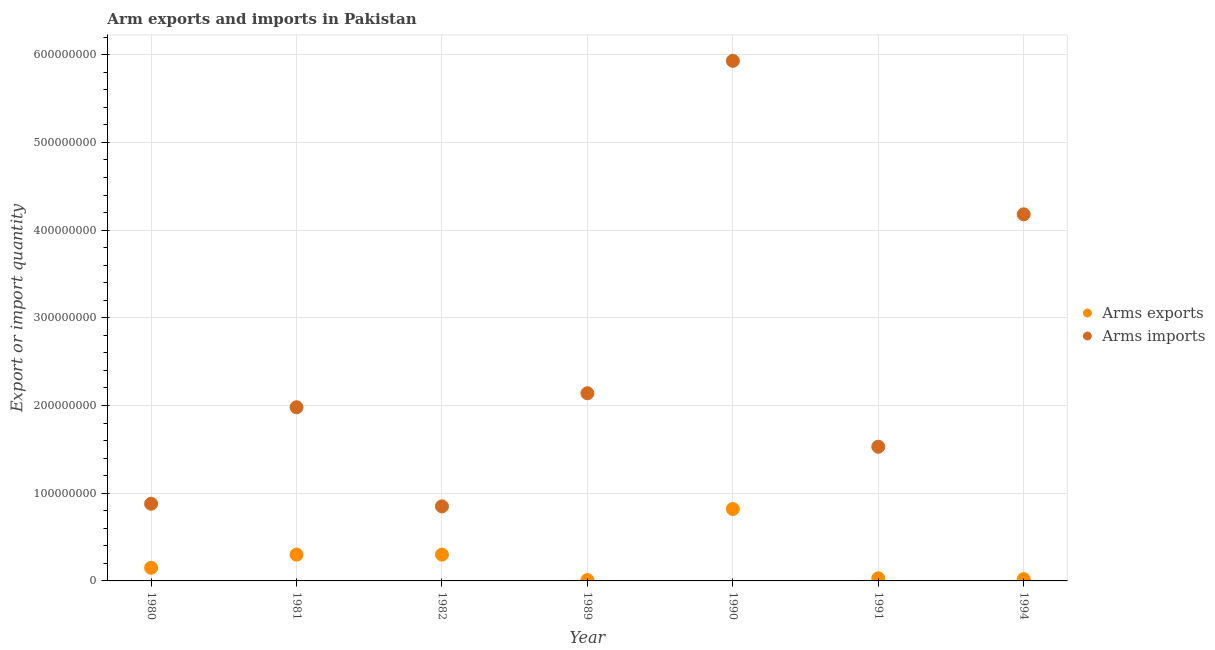What is the arms exports in 1980?
Offer a very short reply. 1.50e+07. Across all years, what is the maximum arms imports?
Offer a terse response. 5.93e+08. Across all years, what is the minimum arms imports?
Make the answer very short. 8.50e+07. In which year was the arms exports minimum?
Your answer should be very brief. 1989. What is the total arms imports in the graph?
Your answer should be very brief. 1.75e+09. What is the difference between the arms exports in 1989 and that in 1991?
Offer a terse response. -2.00e+06. What is the difference between the arms exports in 1994 and the arms imports in 1980?
Ensure brevity in your answer.  -8.60e+07. What is the average arms exports per year?
Give a very brief answer. 2.33e+07. In the year 1991, what is the difference between the arms imports and arms exports?
Offer a terse response. 1.50e+08. In how many years, is the arms exports greater than 380000000?
Offer a very short reply. 0. Is the arms imports in 1982 less than that in 1991?
Your answer should be very brief. Yes. What is the difference between the highest and the second highest arms imports?
Provide a succinct answer. 1.75e+08. What is the difference between the highest and the lowest arms exports?
Make the answer very short. 8.10e+07. In how many years, is the arms imports greater than the average arms imports taken over all years?
Offer a very short reply. 2. Is the sum of the arms imports in 1991 and 1994 greater than the maximum arms exports across all years?
Provide a succinct answer. Yes. Does the arms imports monotonically increase over the years?
Provide a short and direct response. No. How many legend labels are there?
Provide a short and direct response. 2. What is the title of the graph?
Provide a short and direct response. Arm exports and imports in Pakistan. What is the label or title of the Y-axis?
Provide a short and direct response. Export or import quantity. What is the Export or import quantity of Arms exports in 1980?
Keep it short and to the point. 1.50e+07. What is the Export or import quantity in Arms imports in 1980?
Give a very brief answer. 8.80e+07. What is the Export or import quantity of Arms exports in 1981?
Provide a short and direct response. 3.00e+07. What is the Export or import quantity in Arms imports in 1981?
Your answer should be compact. 1.98e+08. What is the Export or import quantity of Arms exports in 1982?
Provide a succinct answer. 3.00e+07. What is the Export or import quantity of Arms imports in 1982?
Your response must be concise. 8.50e+07. What is the Export or import quantity of Arms imports in 1989?
Provide a succinct answer. 2.14e+08. What is the Export or import quantity in Arms exports in 1990?
Provide a succinct answer. 8.20e+07. What is the Export or import quantity of Arms imports in 1990?
Ensure brevity in your answer.  5.93e+08. What is the Export or import quantity of Arms exports in 1991?
Offer a terse response. 3.00e+06. What is the Export or import quantity of Arms imports in 1991?
Make the answer very short. 1.53e+08. What is the Export or import quantity in Arms exports in 1994?
Make the answer very short. 2.00e+06. What is the Export or import quantity in Arms imports in 1994?
Give a very brief answer. 4.18e+08. Across all years, what is the maximum Export or import quantity in Arms exports?
Keep it short and to the point. 8.20e+07. Across all years, what is the maximum Export or import quantity of Arms imports?
Ensure brevity in your answer.  5.93e+08. Across all years, what is the minimum Export or import quantity of Arms exports?
Make the answer very short. 1.00e+06. Across all years, what is the minimum Export or import quantity of Arms imports?
Give a very brief answer. 8.50e+07. What is the total Export or import quantity in Arms exports in the graph?
Provide a succinct answer. 1.63e+08. What is the total Export or import quantity in Arms imports in the graph?
Give a very brief answer. 1.75e+09. What is the difference between the Export or import quantity of Arms exports in 1980 and that in 1981?
Your response must be concise. -1.50e+07. What is the difference between the Export or import quantity of Arms imports in 1980 and that in 1981?
Ensure brevity in your answer.  -1.10e+08. What is the difference between the Export or import quantity in Arms exports in 1980 and that in 1982?
Provide a succinct answer. -1.50e+07. What is the difference between the Export or import quantity in Arms imports in 1980 and that in 1982?
Make the answer very short. 3.00e+06. What is the difference between the Export or import quantity in Arms exports in 1980 and that in 1989?
Your response must be concise. 1.40e+07. What is the difference between the Export or import quantity of Arms imports in 1980 and that in 1989?
Give a very brief answer. -1.26e+08. What is the difference between the Export or import quantity of Arms exports in 1980 and that in 1990?
Provide a succinct answer. -6.70e+07. What is the difference between the Export or import quantity of Arms imports in 1980 and that in 1990?
Your answer should be very brief. -5.05e+08. What is the difference between the Export or import quantity in Arms exports in 1980 and that in 1991?
Offer a terse response. 1.20e+07. What is the difference between the Export or import quantity in Arms imports in 1980 and that in 1991?
Your answer should be compact. -6.50e+07. What is the difference between the Export or import quantity in Arms exports in 1980 and that in 1994?
Offer a very short reply. 1.30e+07. What is the difference between the Export or import quantity of Arms imports in 1980 and that in 1994?
Your answer should be compact. -3.30e+08. What is the difference between the Export or import quantity in Arms imports in 1981 and that in 1982?
Your answer should be very brief. 1.13e+08. What is the difference between the Export or import quantity in Arms exports in 1981 and that in 1989?
Provide a succinct answer. 2.90e+07. What is the difference between the Export or import quantity in Arms imports in 1981 and that in 1989?
Your answer should be compact. -1.60e+07. What is the difference between the Export or import quantity of Arms exports in 1981 and that in 1990?
Offer a terse response. -5.20e+07. What is the difference between the Export or import quantity of Arms imports in 1981 and that in 1990?
Keep it short and to the point. -3.95e+08. What is the difference between the Export or import quantity of Arms exports in 1981 and that in 1991?
Your response must be concise. 2.70e+07. What is the difference between the Export or import quantity in Arms imports in 1981 and that in 1991?
Make the answer very short. 4.50e+07. What is the difference between the Export or import quantity in Arms exports in 1981 and that in 1994?
Offer a terse response. 2.80e+07. What is the difference between the Export or import quantity of Arms imports in 1981 and that in 1994?
Your answer should be compact. -2.20e+08. What is the difference between the Export or import quantity of Arms exports in 1982 and that in 1989?
Offer a terse response. 2.90e+07. What is the difference between the Export or import quantity in Arms imports in 1982 and that in 1989?
Provide a short and direct response. -1.29e+08. What is the difference between the Export or import quantity of Arms exports in 1982 and that in 1990?
Ensure brevity in your answer.  -5.20e+07. What is the difference between the Export or import quantity in Arms imports in 1982 and that in 1990?
Offer a very short reply. -5.08e+08. What is the difference between the Export or import quantity of Arms exports in 1982 and that in 1991?
Offer a very short reply. 2.70e+07. What is the difference between the Export or import quantity of Arms imports in 1982 and that in 1991?
Offer a terse response. -6.80e+07. What is the difference between the Export or import quantity of Arms exports in 1982 and that in 1994?
Your answer should be very brief. 2.80e+07. What is the difference between the Export or import quantity of Arms imports in 1982 and that in 1994?
Your answer should be very brief. -3.33e+08. What is the difference between the Export or import quantity in Arms exports in 1989 and that in 1990?
Ensure brevity in your answer.  -8.10e+07. What is the difference between the Export or import quantity of Arms imports in 1989 and that in 1990?
Keep it short and to the point. -3.79e+08. What is the difference between the Export or import quantity of Arms exports in 1989 and that in 1991?
Keep it short and to the point. -2.00e+06. What is the difference between the Export or import quantity of Arms imports in 1989 and that in 1991?
Keep it short and to the point. 6.10e+07. What is the difference between the Export or import quantity of Arms exports in 1989 and that in 1994?
Your response must be concise. -1.00e+06. What is the difference between the Export or import quantity of Arms imports in 1989 and that in 1994?
Offer a very short reply. -2.04e+08. What is the difference between the Export or import quantity in Arms exports in 1990 and that in 1991?
Ensure brevity in your answer.  7.90e+07. What is the difference between the Export or import quantity of Arms imports in 1990 and that in 1991?
Your answer should be compact. 4.40e+08. What is the difference between the Export or import quantity in Arms exports in 1990 and that in 1994?
Keep it short and to the point. 8.00e+07. What is the difference between the Export or import quantity in Arms imports in 1990 and that in 1994?
Your answer should be very brief. 1.75e+08. What is the difference between the Export or import quantity of Arms exports in 1991 and that in 1994?
Your answer should be compact. 1.00e+06. What is the difference between the Export or import quantity of Arms imports in 1991 and that in 1994?
Your answer should be very brief. -2.65e+08. What is the difference between the Export or import quantity in Arms exports in 1980 and the Export or import quantity in Arms imports in 1981?
Provide a succinct answer. -1.83e+08. What is the difference between the Export or import quantity of Arms exports in 1980 and the Export or import quantity of Arms imports in 1982?
Keep it short and to the point. -7.00e+07. What is the difference between the Export or import quantity of Arms exports in 1980 and the Export or import quantity of Arms imports in 1989?
Your answer should be compact. -1.99e+08. What is the difference between the Export or import quantity of Arms exports in 1980 and the Export or import quantity of Arms imports in 1990?
Make the answer very short. -5.78e+08. What is the difference between the Export or import quantity in Arms exports in 1980 and the Export or import quantity in Arms imports in 1991?
Your answer should be very brief. -1.38e+08. What is the difference between the Export or import quantity in Arms exports in 1980 and the Export or import quantity in Arms imports in 1994?
Ensure brevity in your answer.  -4.03e+08. What is the difference between the Export or import quantity in Arms exports in 1981 and the Export or import quantity in Arms imports in 1982?
Your answer should be compact. -5.50e+07. What is the difference between the Export or import quantity of Arms exports in 1981 and the Export or import quantity of Arms imports in 1989?
Your answer should be compact. -1.84e+08. What is the difference between the Export or import quantity in Arms exports in 1981 and the Export or import quantity in Arms imports in 1990?
Your answer should be compact. -5.63e+08. What is the difference between the Export or import quantity in Arms exports in 1981 and the Export or import quantity in Arms imports in 1991?
Your response must be concise. -1.23e+08. What is the difference between the Export or import quantity of Arms exports in 1981 and the Export or import quantity of Arms imports in 1994?
Provide a short and direct response. -3.88e+08. What is the difference between the Export or import quantity in Arms exports in 1982 and the Export or import quantity in Arms imports in 1989?
Your answer should be compact. -1.84e+08. What is the difference between the Export or import quantity in Arms exports in 1982 and the Export or import quantity in Arms imports in 1990?
Your response must be concise. -5.63e+08. What is the difference between the Export or import quantity of Arms exports in 1982 and the Export or import quantity of Arms imports in 1991?
Ensure brevity in your answer.  -1.23e+08. What is the difference between the Export or import quantity in Arms exports in 1982 and the Export or import quantity in Arms imports in 1994?
Provide a succinct answer. -3.88e+08. What is the difference between the Export or import quantity of Arms exports in 1989 and the Export or import quantity of Arms imports in 1990?
Provide a succinct answer. -5.92e+08. What is the difference between the Export or import quantity in Arms exports in 1989 and the Export or import quantity in Arms imports in 1991?
Make the answer very short. -1.52e+08. What is the difference between the Export or import quantity in Arms exports in 1989 and the Export or import quantity in Arms imports in 1994?
Offer a very short reply. -4.17e+08. What is the difference between the Export or import quantity of Arms exports in 1990 and the Export or import quantity of Arms imports in 1991?
Your answer should be very brief. -7.10e+07. What is the difference between the Export or import quantity of Arms exports in 1990 and the Export or import quantity of Arms imports in 1994?
Offer a very short reply. -3.36e+08. What is the difference between the Export or import quantity of Arms exports in 1991 and the Export or import quantity of Arms imports in 1994?
Keep it short and to the point. -4.15e+08. What is the average Export or import quantity in Arms exports per year?
Offer a very short reply. 2.33e+07. What is the average Export or import quantity in Arms imports per year?
Ensure brevity in your answer.  2.50e+08. In the year 1980, what is the difference between the Export or import quantity in Arms exports and Export or import quantity in Arms imports?
Your answer should be very brief. -7.30e+07. In the year 1981, what is the difference between the Export or import quantity of Arms exports and Export or import quantity of Arms imports?
Your response must be concise. -1.68e+08. In the year 1982, what is the difference between the Export or import quantity of Arms exports and Export or import quantity of Arms imports?
Offer a terse response. -5.50e+07. In the year 1989, what is the difference between the Export or import quantity of Arms exports and Export or import quantity of Arms imports?
Keep it short and to the point. -2.13e+08. In the year 1990, what is the difference between the Export or import quantity of Arms exports and Export or import quantity of Arms imports?
Ensure brevity in your answer.  -5.11e+08. In the year 1991, what is the difference between the Export or import quantity in Arms exports and Export or import quantity in Arms imports?
Make the answer very short. -1.50e+08. In the year 1994, what is the difference between the Export or import quantity of Arms exports and Export or import quantity of Arms imports?
Offer a very short reply. -4.16e+08. What is the ratio of the Export or import quantity in Arms exports in 1980 to that in 1981?
Ensure brevity in your answer.  0.5. What is the ratio of the Export or import quantity of Arms imports in 1980 to that in 1981?
Keep it short and to the point. 0.44. What is the ratio of the Export or import quantity of Arms imports in 1980 to that in 1982?
Keep it short and to the point. 1.04. What is the ratio of the Export or import quantity in Arms exports in 1980 to that in 1989?
Provide a short and direct response. 15. What is the ratio of the Export or import quantity in Arms imports in 1980 to that in 1989?
Provide a short and direct response. 0.41. What is the ratio of the Export or import quantity in Arms exports in 1980 to that in 1990?
Your response must be concise. 0.18. What is the ratio of the Export or import quantity in Arms imports in 1980 to that in 1990?
Offer a very short reply. 0.15. What is the ratio of the Export or import quantity of Arms imports in 1980 to that in 1991?
Your answer should be very brief. 0.58. What is the ratio of the Export or import quantity of Arms imports in 1980 to that in 1994?
Make the answer very short. 0.21. What is the ratio of the Export or import quantity of Arms exports in 1981 to that in 1982?
Offer a terse response. 1. What is the ratio of the Export or import quantity of Arms imports in 1981 to that in 1982?
Give a very brief answer. 2.33. What is the ratio of the Export or import quantity in Arms imports in 1981 to that in 1989?
Your answer should be compact. 0.93. What is the ratio of the Export or import quantity of Arms exports in 1981 to that in 1990?
Your answer should be very brief. 0.37. What is the ratio of the Export or import quantity in Arms imports in 1981 to that in 1990?
Keep it short and to the point. 0.33. What is the ratio of the Export or import quantity in Arms exports in 1981 to that in 1991?
Your response must be concise. 10. What is the ratio of the Export or import quantity of Arms imports in 1981 to that in 1991?
Keep it short and to the point. 1.29. What is the ratio of the Export or import quantity in Arms imports in 1981 to that in 1994?
Your answer should be very brief. 0.47. What is the ratio of the Export or import quantity of Arms exports in 1982 to that in 1989?
Ensure brevity in your answer.  30. What is the ratio of the Export or import quantity of Arms imports in 1982 to that in 1989?
Offer a terse response. 0.4. What is the ratio of the Export or import quantity of Arms exports in 1982 to that in 1990?
Make the answer very short. 0.37. What is the ratio of the Export or import quantity in Arms imports in 1982 to that in 1990?
Provide a succinct answer. 0.14. What is the ratio of the Export or import quantity in Arms imports in 1982 to that in 1991?
Your answer should be very brief. 0.56. What is the ratio of the Export or import quantity of Arms exports in 1982 to that in 1994?
Keep it short and to the point. 15. What is the ratio of the Export or import quantity in Arms imports in 1982 to that in 1994?
Provide a short and direct response. 0.2. What is the ratio of the Export or import quantity of Arms exports in 1989 to that in 1990?
Provide a short and direct response. 0.01. What is the ratio of the Export or import quantity of Arms imports in 1989 to that in 1990?
Your response must be concise. 0.36. What is the ratio of the Export or import quantity of Arms exports in 1989 to that in 1991?
Keep it short and to the point. 0.33. What is the ratio of the Export or import quantity of Arms imports in 1989 to that in 1991?
Provide a succinct answer. 1.4. What is the ratio of the Export or import quantity in Arms exports in 1989 to that in 1994?
Ensure brevity in your answer.  0.5. What is the ratio of the Export or import quantity in Arms imports in 1989 to that in 1994?
Your answer should be compact. 0.51. What is the ratio of the Export or import quantity of Arms exports in 1990 to that in 1991?
Give a very brief answer. 27.33. What is the ratio of the Export or import quantity of Arms imports in 1990 to that in 1991?
Offer a very short reply. 3.88. What is the ratio of the Export or import quantity in Arms imports in 1990 to that in 1994?
Your answer should be compact. 1.42. What is the ratio of the Export or import quantity of Arms exports in 1991 to that in 1994?
Keep it short and to the point. 1.5. What is the ratio of the Export or import quantity in Arms imports in 1991 to that in 1994?
Keep it short and to the point. 0.37. What is the difference between the highest and the second highest Export or import quantity of Arms exports?
Provide a succinct answer. 5.20e+07. What is the difference between the highest and the second highest Export or import quantity of Arms imports?
Offer a terse response. 1.75e+08. What is the difference between the highest and the lowest Export or import quantity in Arms exports?
Provide a short and direct response. 8.10e+07. What is the difference between the highest and the lowest Export or import quantity in Arms imports?
Provide a succinct answer. 5.08e+08. 